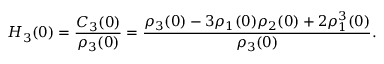Convert formula to latex. <formula><loc_0><loc_0><loc_500><loc_500>H _ { 3 } ( 0 ) = \frac { C _ { 3 } ( 0 ) } { \rho _ { 3 } ( 0 ) } = \frac { \rho _ { 3 } ( 0 ) - 3 \rho _ { 1 } ( 0 ) \rho _ { 2 } ( 0 ) + 2 \rho _ { 1 } ^ { 3 } ( 0 ) } { \rho _ { 3 } ( 0 ) } .</formula> 